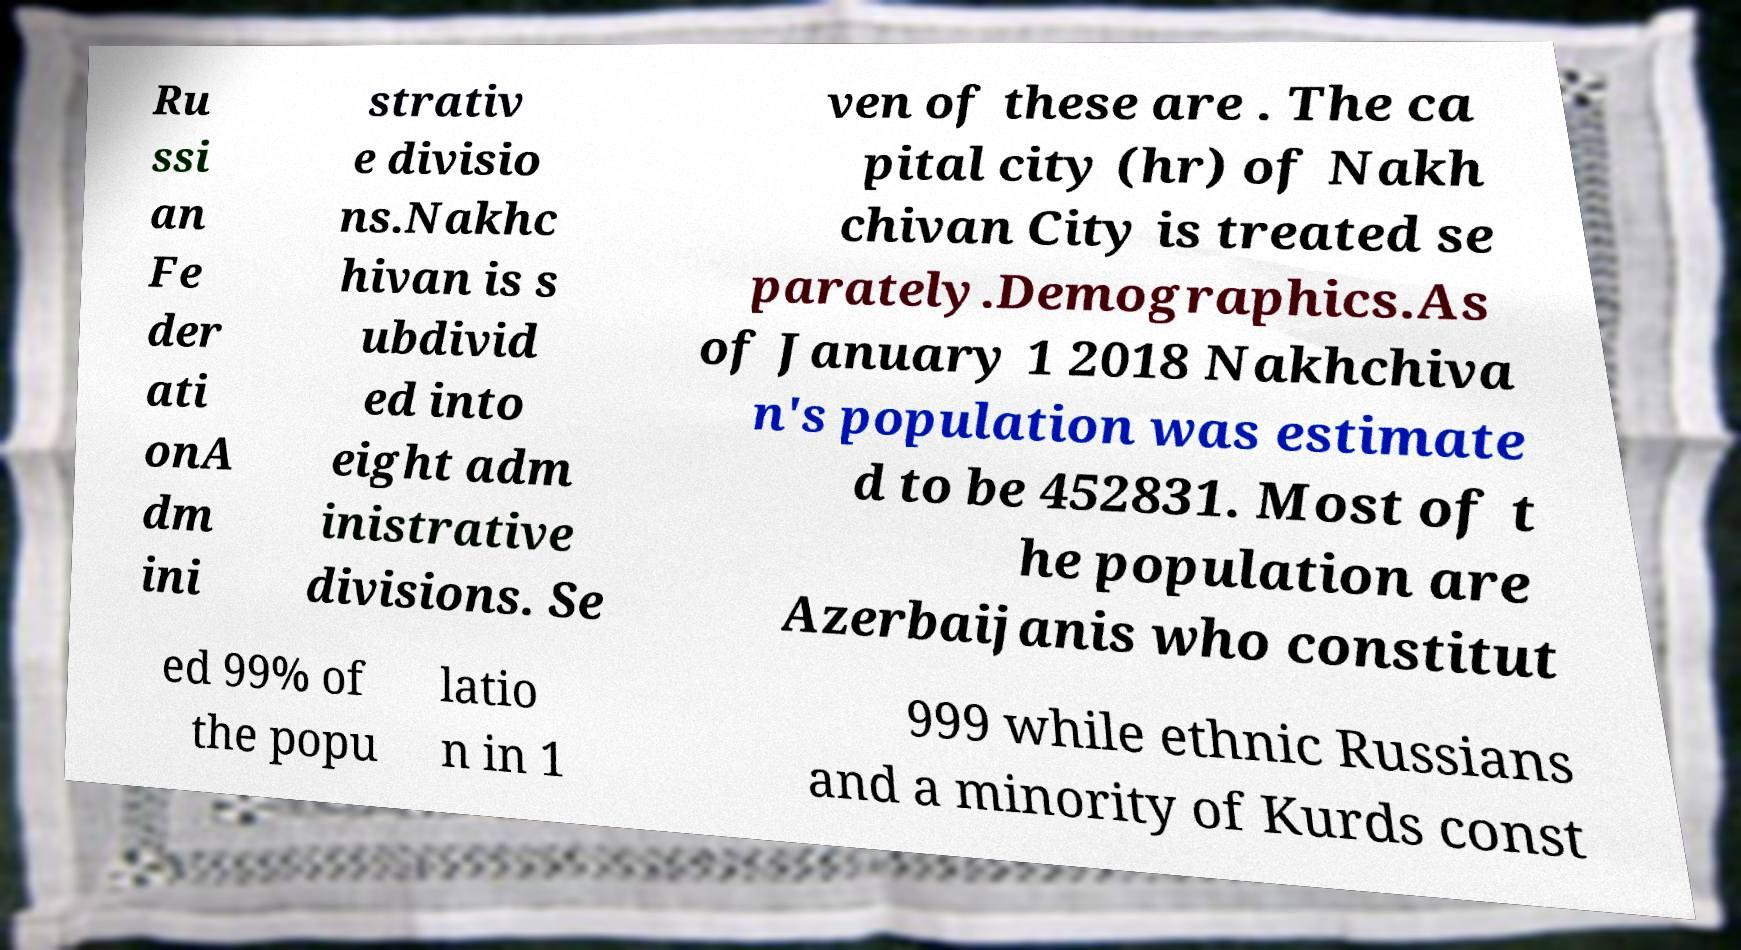I need the written content from this picture converted into text. Can you do that? Ru ssi an Fe der ati onA dm ini strativ e divisio ns.Nakhc hivan is s ubdivid ed into eight adm inistrative divisions. Se ven of these are . The ca pital city (hr) of Nakh chivan City is treated se parately.Demographics.As of January 1 2018 Nakhchiva n's population was estimate d to be 452831. Most of t he population are Azerbaijanis who constitut ed 99% of the popu latio n in 1 999 while ethnic Russians and a minority of Kurds const 